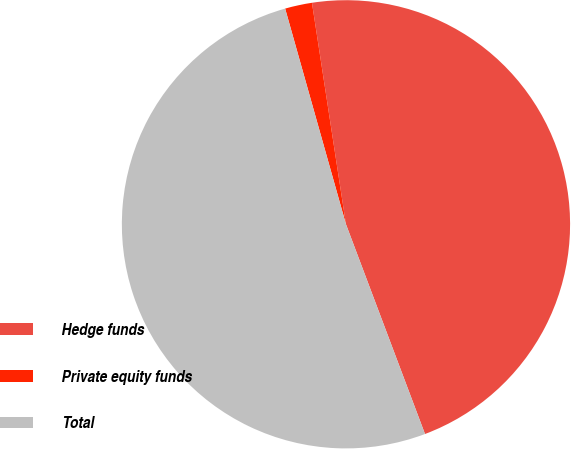Convert chart. <chart><loc_0><loc_0><loc_500><loc_500><pie_chart><fcel>Hedge funds<fcel>Private equity funds<fcel>Total<nl><fcel>46.69%<fcel>1.95%<fcel>51.36%<nl></chart> 